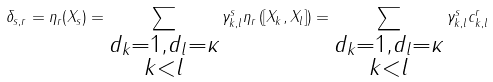Convert formula to latex. <formula><loc_0><loc_0><loc_500><loc_500>\delta _ { s , r } = \eta _ { r } ( X _ { s } ) = \sum _ { \substack { d _ { k } = 1 , d _ { l } = \kappa \\ k < l } } \gamma _ { k , l } ^ { s } \eta _ { r } \left ( [ X _ { k } , X _ { l } ] \right ) = \sum _ { \substack { d _ { k } = 1 , d _ { l } = \kappa \\ k < l } } \gamma _ { k , l } ^ { s } c _ { k , l } ^ { r }</formula> 